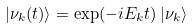Convert formula to latex. <formula><loc_0><loc_0><loc_500><loc_500>| \nu _ { k } ( t ) \rangle = \exp ( - i E _ { k } t ) \, | \nu _ { k } \rangle</formula> 